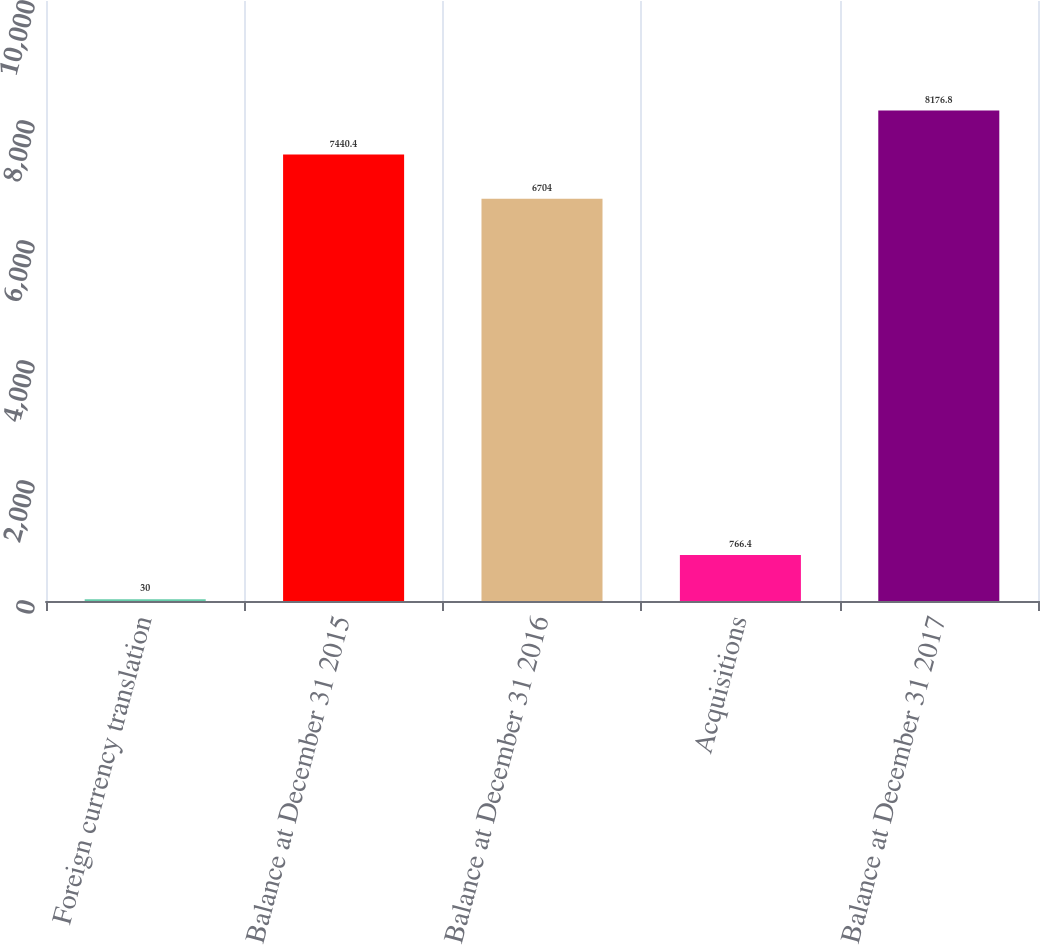<chart> <loc_0><loc_0><loc_500><loc_500><bar_chart><fcel>Foreign currency translation<fcel>Balance at December 31 2015<fcel>Balance at December 31 2016<fcel>Acquisitions<fcel>Balance at December 31 2017<nl><fcel>30<fcel>7440.4<fcel>6704<fcel>766.4<fcel>8176.8<nl></chart> 